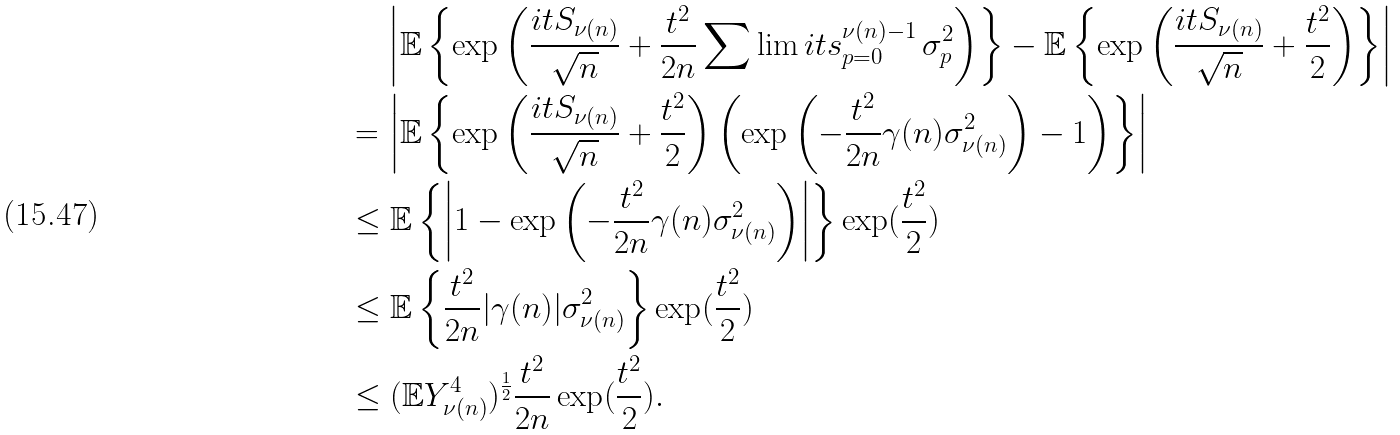<formula> <loc_0><loc_0><loc_500><loc_500>& \quad \, \left | \mathbb { E } \left \{ \exp \left ( \frac { i t S _ { \nu ( n ) } } { \sqrt { n } } + \frac { t ^ { 2 } } { 2 n } \sum \lim i t s _ { p = 0 } ^ { \nu ( n ) - 1 } \, \sigma _ { p } ^ { 2 } \right ) \right \} - \mathbb { E } \left \{ \exp \left ( \frac { i t S _ { \nu ( n ) } } { \sqrt { n } } + \frac { t ^ { 2 } } { 2 } \right ) \right \} \right | \\ & = \left | \mathbb { E } \left \{ \exp \left ( \frac { i t S _ { \nu ( n ) } } { \sqrt { n } } + \frac { t ^ { 2 } } { 2 } \right ) \left ( \exp \left ( - \frac { t ^ { 2 } } { 2 n } \gamma ( n ) \sigma _ { \nu ( n ) } ^ { 2 } \right ) - 1 \right ) \right \} \right | \\ & \leq \mathbb { E } \left \{ \left | 1 - \exp \left ( - \frac { t ^ { 2 } } { 2 n } \gamma ( n ) \sigma _ { \nu ( n ) } ^ { 2 } \right ) \right | \right \} \exp ( \frac { t ^ { 2 } } { 2 } ) \\ & \leq \mathbb { E } \left \{ \frac { t ^ { 2 } } { 2 n } | \gamma ( n ) | \sigma _ { \nu ( n ) } ^ { 2 } \right \} \exp ( \frac { t ^ { 2 } } { 2 } ) \\ & \leq ( \mathbb { E } Y _ { \nu ( n ) } ^ { 4 } ) ^ { \frac { 1 } { 2 } } \frac { t ^ { 2 } } { 2 n } \exp ( \frac { t ^ { 2 } } { 2 } ) .</formula> 